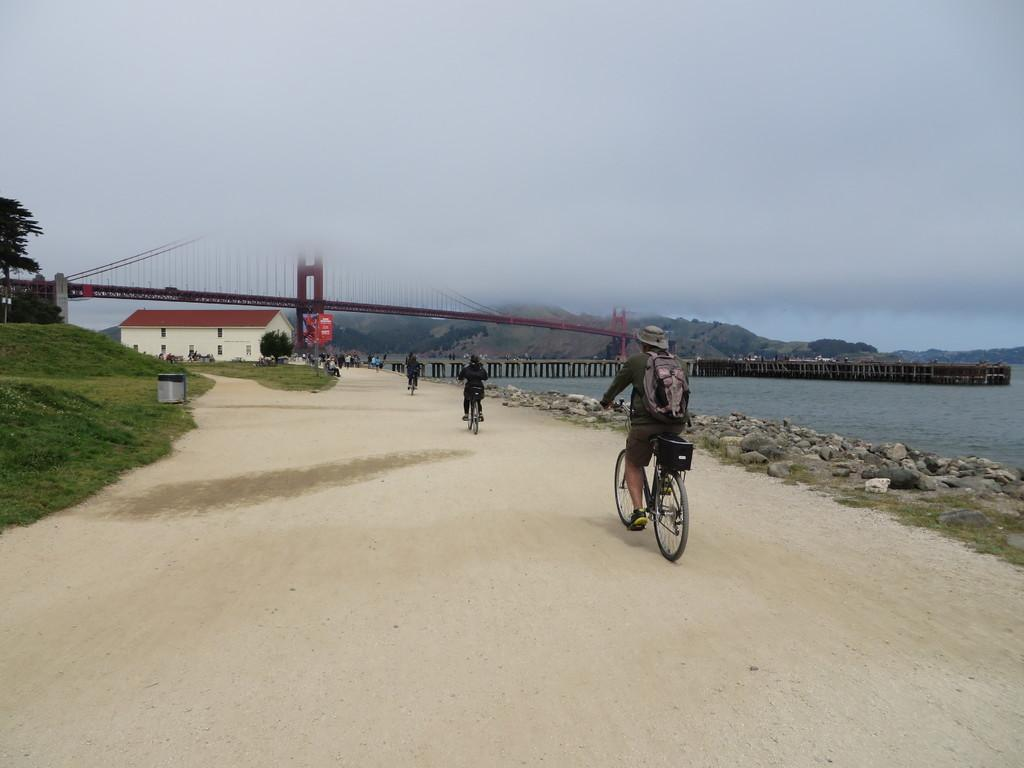What are the people in the image doing? The people in the image are cyclists. Where are the cyclists riding? The cyclists are riding on the ground. What type of house can be seen in the image? There is a white-colored house with red tiles in the image. What feature does the house have? The house has a shaded area. What structure is present in the image? There is a big iron bridge in the image. What can be seen in the distance in the image? Mountains are visible in the background. What time does the clock on the bridge show in the image? There is no clock present on the bridge in the image. What type of rail is used for the cyclists to ride on in the image? The cyclists are riding on the ground, not a rail, in the image. Is there an umbrella providing shade for the cyclists in the image? There is no umbrella visible in the image; the house has a shaded area. 